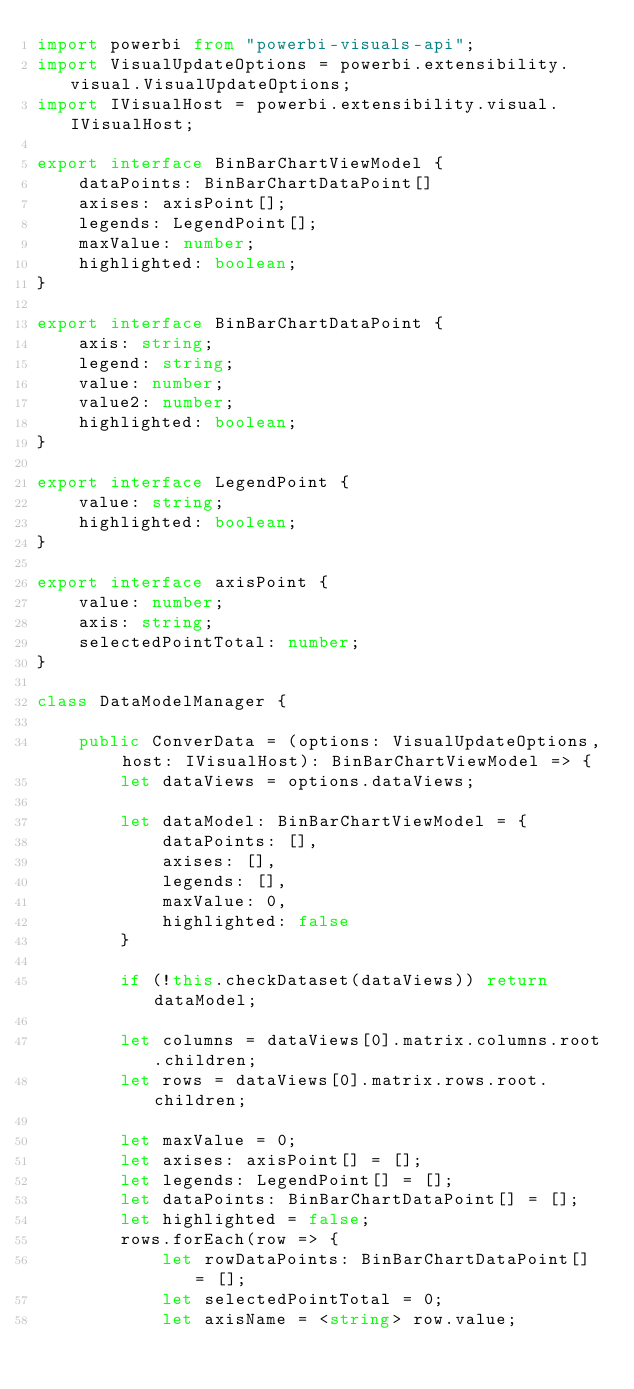Convert code to text. <code><loc_0><loc_0><loc_500><loc_500><_TypeScript_>import powerbi from "powerbi-visuals-api";
import VisualUpdateOptions = powerbi.extensibility.visual.VisualUpdateOptions;
import IVisualHost = powerbi.extensibility.visual.IVisualHost;

export interface BinBarChartViewModel {
    dataPoints: BinBarChartDataPoint[]
    axises: axisPoint[];
    legends: LegendPoint[];
    maxValue: number;
    highlighted: boolean;
}

export interface BinBarChartDataPoint {
    axis: string;
    legend: string;
    value: number;
    value2: number;
    highlighted: boolean;
}

export interface LegendPoint {
    value: string;
    highlighted: boolean;
}

export interface axisPoint {
    value: number;
    axis: string;
    selectedPointTotal: number;
}

class DataModelManager {

    public ConverData = (options: VisualUpdateOptions, host: IVisualHost): BinBarChartViewModel => {
        let dataViews = options.dataViews;

        let dataModel: BinBarChartViewModel = {
            dataPoints: [],
            axises: [],
            legends: [],
            maxValue: 0,
            highlighted: false
        }

        if (!this.checkDataset(dataViews)) return dataModel;

        let columns = dataViews[0].matrix.columns.root.children;
        let rows = dataViews[0].matrix.rows.root.children;

        let maxValue = 0;
        let axises: axisPoint[] = [];
        let legends: LegendPoint[] = [];
        let dataPoints: BinBarChartDataPoint[] = [];
        let highlighted = false;
        rows.forEach(row => {
            let rowDataPoints: BinBarChartDataPoint[] = [];
            let selectedPointTotal = 0;
            let axisName = <string> row.value;
</code> 